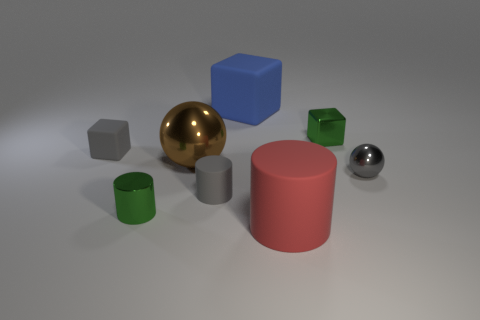Add 1 big green blocks. How many objects exist? 9 Subtract all cylinders. How many objects are left? 5 Add 4 gray shiny objects. How many gray shiny objects are left? 5 Add 6 small purple metallic cylinders. How many small purple metallic cylinders exist? 6 Subtract 1 brown balls. How many objects are left? 7 Subtract all big blue matte things. Subtract all green cylinders. How many objects are left? 6 